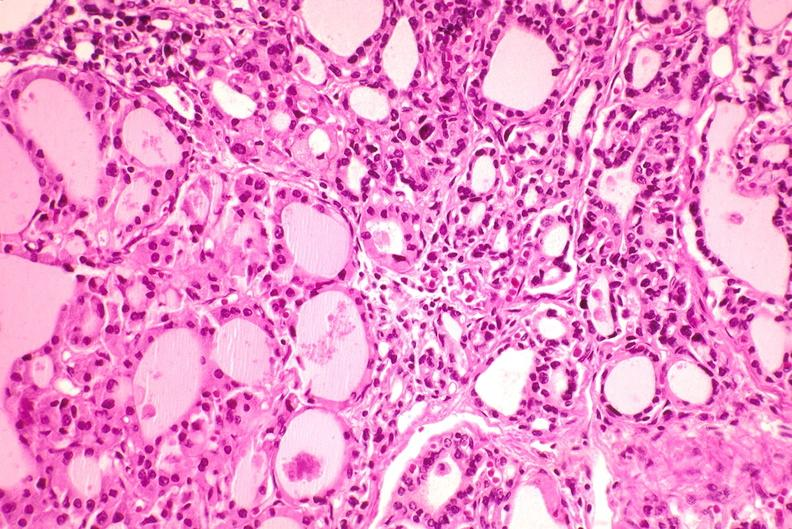what is present?
Answer the question using a single word or phrase. Endocrine 